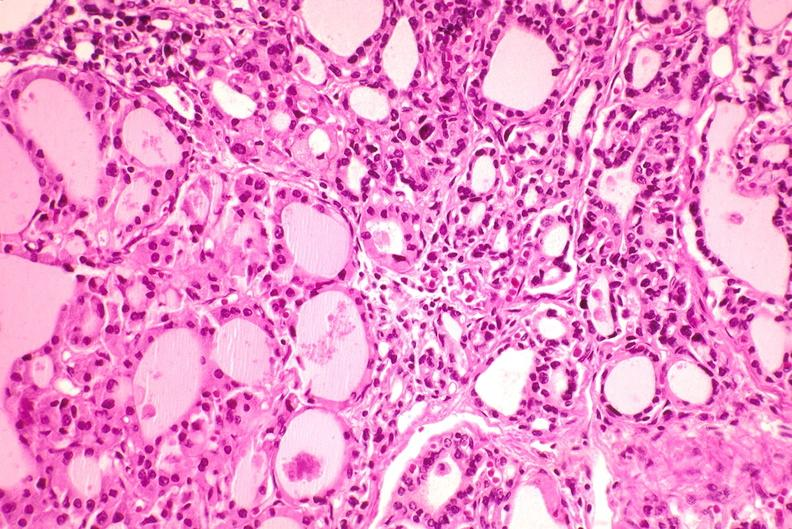what is present?
Answer the question using a single word or phrase. Endocrine 